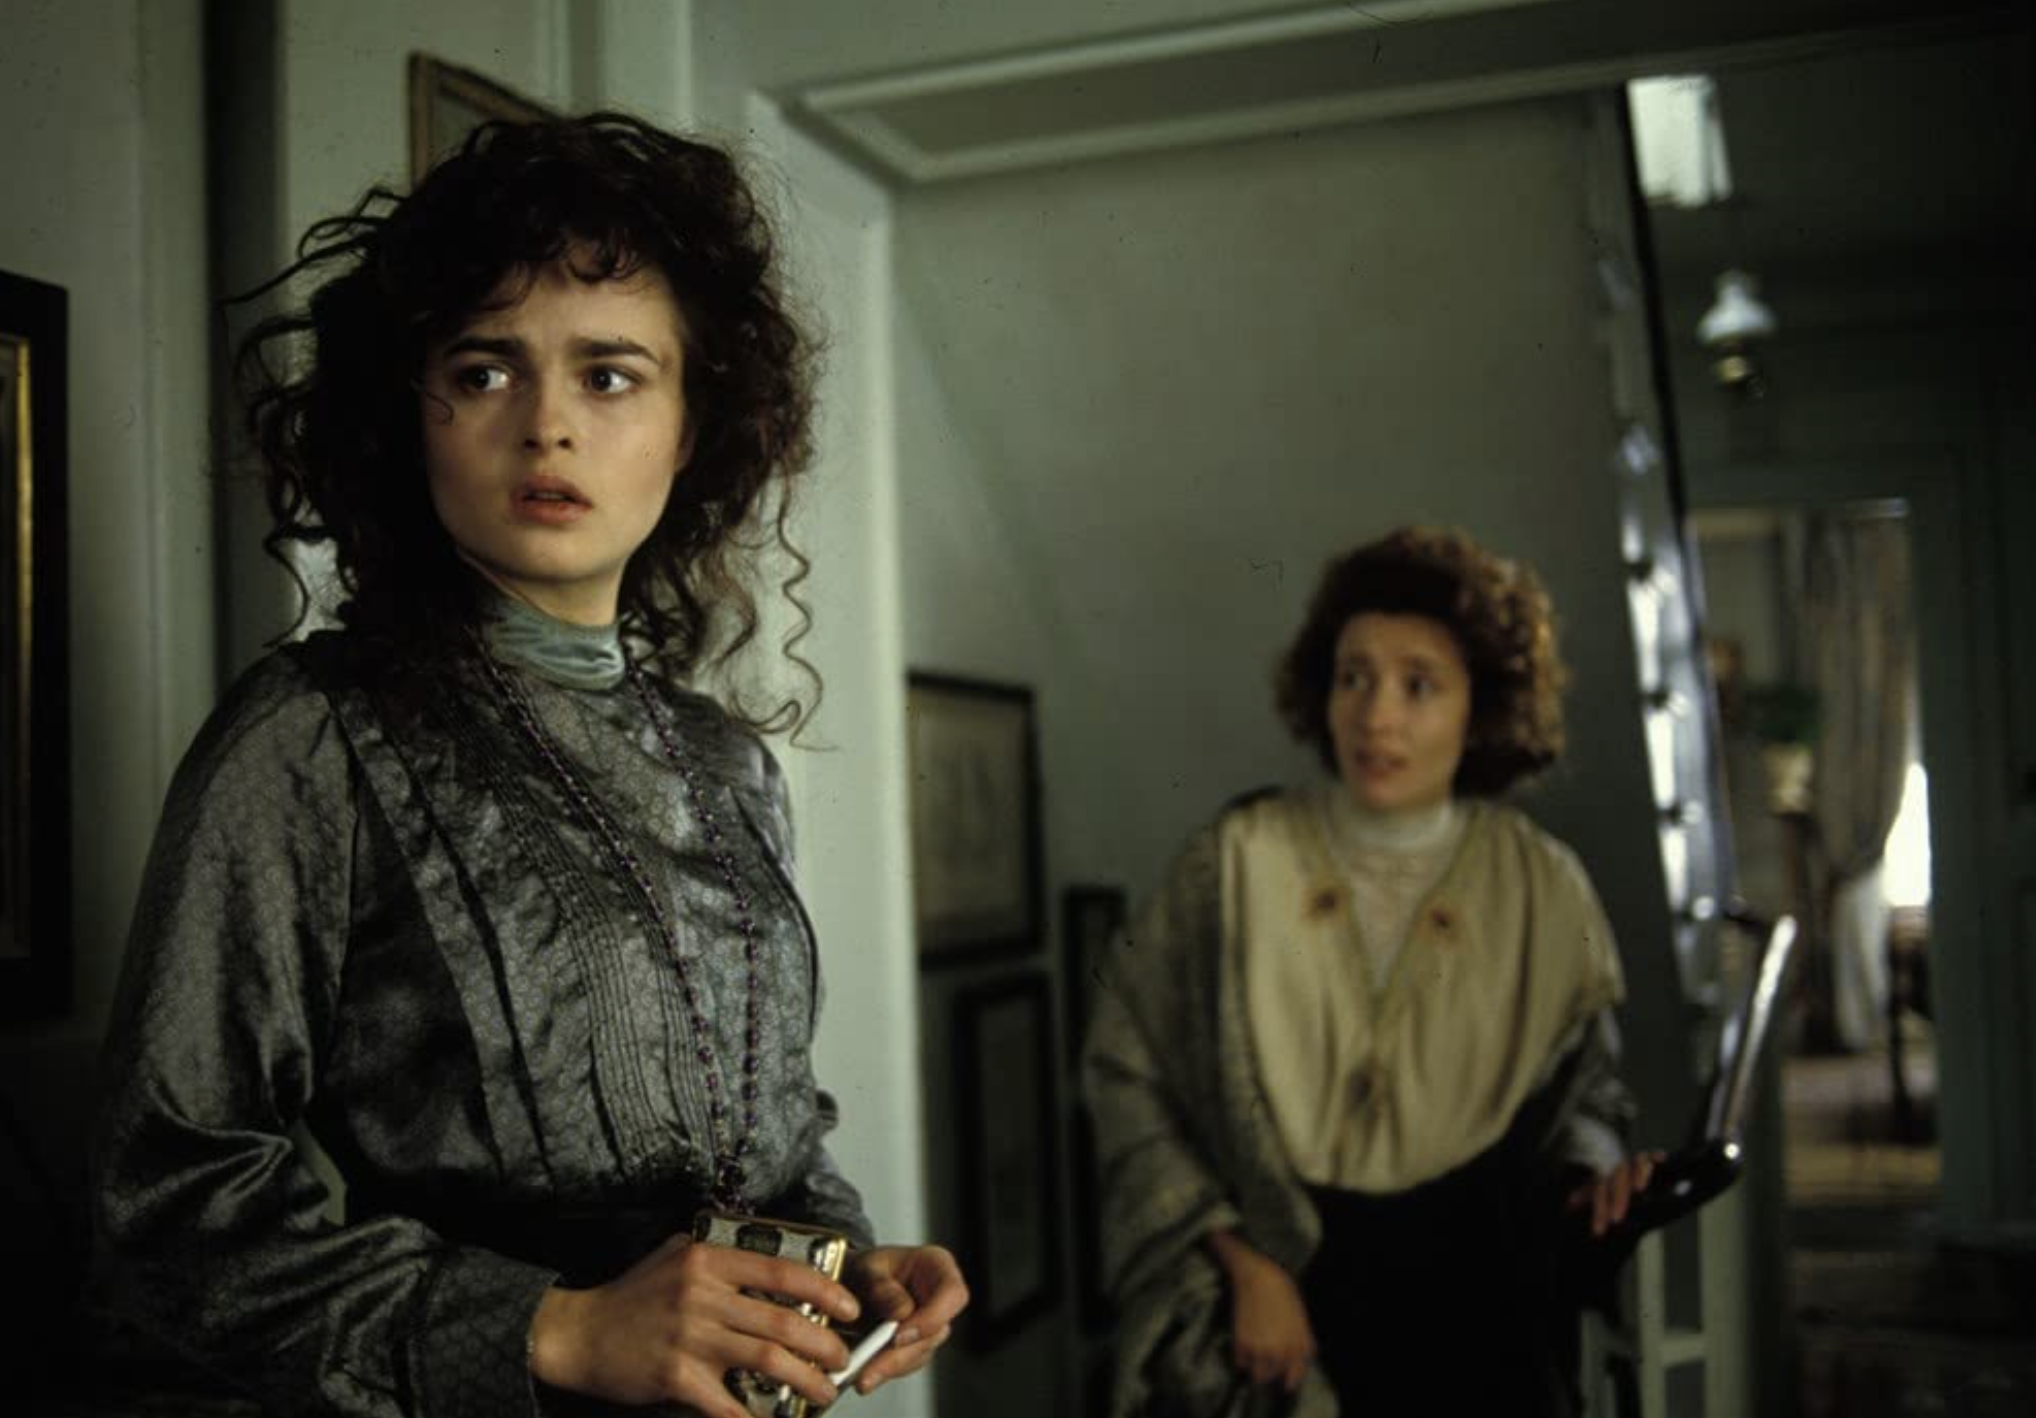Imagine Lucy remains standing by the door after this moment. What might she be thinking? If Lucy remains standing by the door, she might be reflecting on the implications of the conversation she just had with Charlotte. Her thoughts may be racing, weighed down by uncertainty and the gravity of what she just learned. She might also be struggling to formulate a plan or response, considering the potential impact on her future and the relationships she holds dear. Create a monologue for Lucy, expressing her thoughts in this scene. How could this happen? Everything seemed so perfect just a moment ago. Charlotte's words echo in my mind, and I can't seem to shake this feeling of impending doom. I must stay calm, but how? Her news changes everything. Perhaps... perhaps there is a way out of this, a way to turn things around. But what if there isn't? What if I must face the consequences head-on, with no escape? I look to the door, imagining a world beyond this room, free of these troubles. If only it were that simple...  